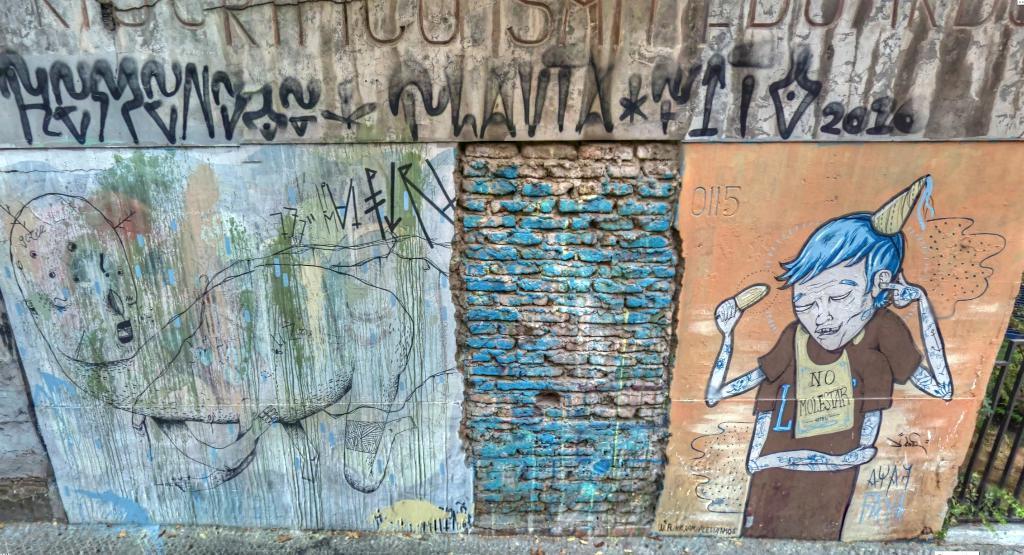Can you describe this image briefly? In this image there are paintings and words on the wall, and there are iron grills, plants. 